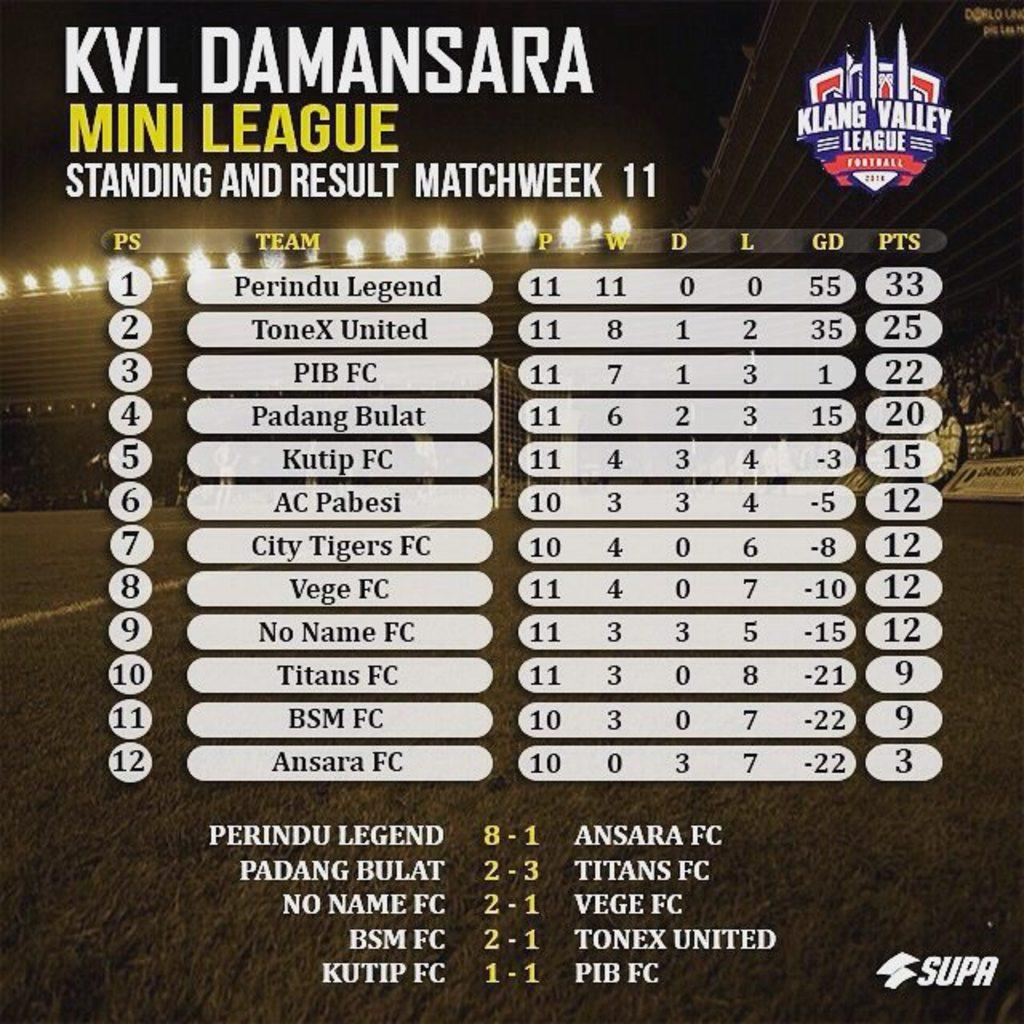<image>
Write a terse but informative summary of the picture. the klang valley league has 12 games on the matchup 